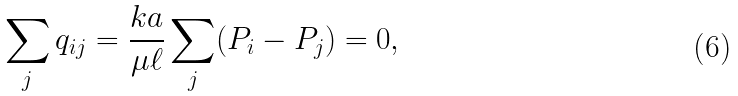<formula> <loc_0><loc_0><loc_500><loc_500>\sum _ { j } { q } _ { i j } = \frac { k a } { \mu \ell } \sum _ { j } ( { P } _ { i } - { P } _ { j } ) = 0 ,</formula> 